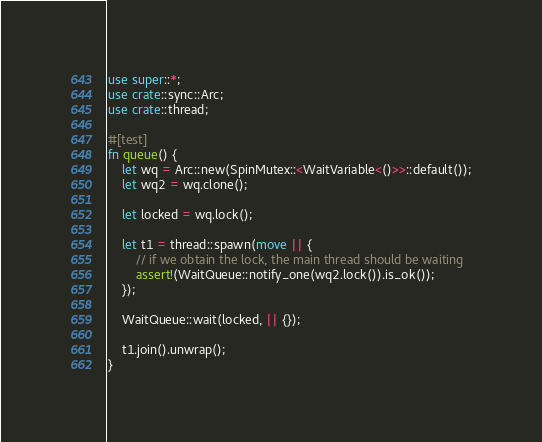Convert code to text. <code><loc_0><loc_0><loc_500><loc_500><_Rust_>use super::*;
use crate::sync::Arc;
use crate::thread;

#[test]
fn queue() {
    let wq = Arc::new(SpinMutex::<WaitVariable<()>>::default());
    let wq2 = wq.clone();

    let locked = wq.lock();

    let t1 = thread::spawn(move || {
        // if we obtain the lock, the main thread should be waiting
        assert!(WaitQueue::notify_one(wq2.lock()).is_ok());
    });

    WaitQueue::wait(locked, || {});

    t1.join().unwrap();
}
</code> 